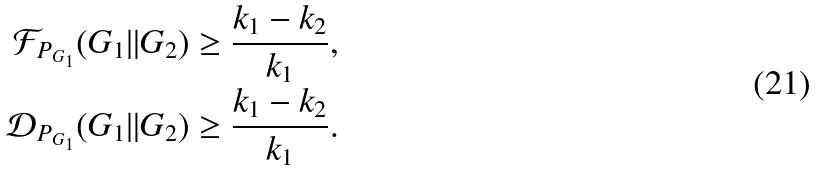<formula> <loc_0><loc_0><loc_500><loc_500>\mathcal { F } _ { P _ { G _ { 1 } } } ( G _ { 1 } \| G _ { 2 } ) & \geq \frac { k _ { 1 } - k _ { 2 } } { k _ { 1 } } , \\ \mathcal { D } _ { P _ { G _ { 1 } } } ( G _ { 1 } \| G _ { 2 } ) & \geq \frac { k _ { 1 } - k _ { 2 } } { k _ { 1 } } .</formula> 